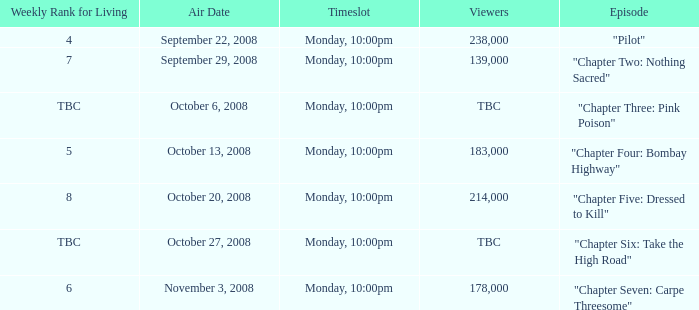What is the episode with the 183,000 viewers? "Chapter Four: Bombay Highway". 